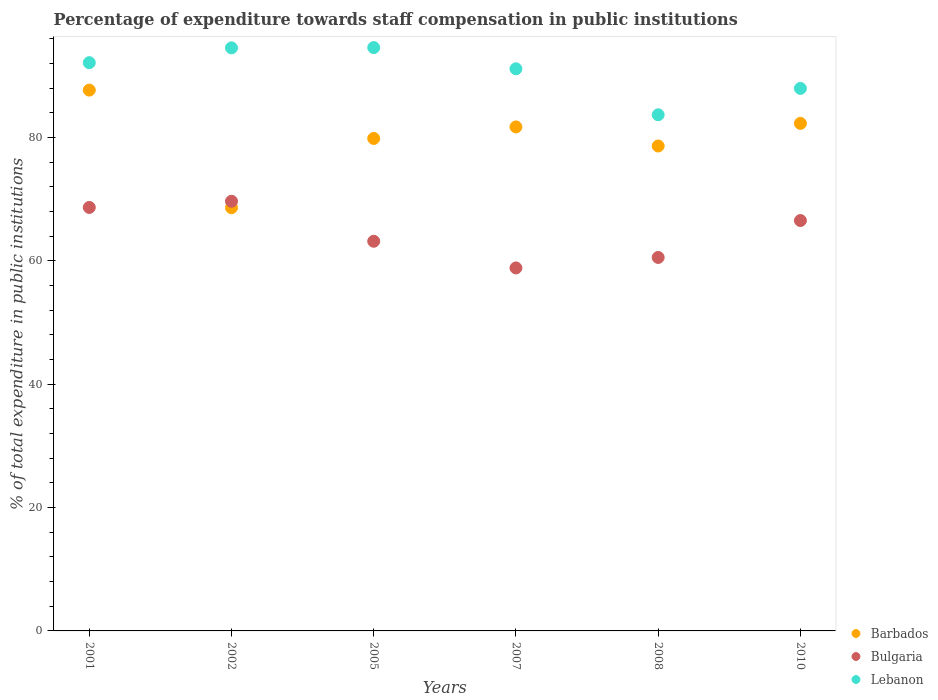What is the percentage of expenditure towards staff compensation in Bulgaria in 2010?
Offer a very short reply. 66.56. Across all years, what is the maximum percentage of expenditure towards staff compensation in Bulgaria?
Your response must be concise. 69.68. Across all years, what is the minimum percentage of expenditure towards staff compensation in Lebanon?
Your response must be concise. 83.71. In which year was the percentage of expenditure towards staff compensation in Bulgaria maximum?
Offer a terse response. 2002. In which year was the percentage of expenditure towards staff compensation in Lebanon minimum?
Your answer should be very brief. 2008. What is the total percentage of expenditure towards staff compensation in Bulgaria in the graph?
Make the answer very short. 387.56. What is the difference between the percentage of expenditure towards staff compensation in Lebanon in 2005 and that in 2007?
Keep it short and to the point. 3.44. What is the difference between the percentage of expenditure towards staff compensation in Lebanon in 2007 and the percentage of expenditure towards staff compensation in Bulgaria in 2010?
Keep it short and to the point. 24.61. What is the average percentage of expenditure towards staff compensation in Barbados per year?
Your response must be concise. 79.82. In the year 2007, what is the difference between the percentage of expenditure towards staff compensation in Barbados and percentage of expenditure towards staff compensation in Lebanon?
Your response must be concise. -9.42. What is the ratio of the percentage of expenditure towards staff compensation in Lebanon in 2001 to that in 2010?
Your answer should be very brief. 1.05. Is the percentage of expenditure towards staff compensation in Bulgaria in 2002 less than that in 2005?
Offer a terse response. No. Is the difference between the percentage of expenditure towards staff compensation in Barbados in 2008 and 2010 greater than the difference between the percentage of expenditure towards staff compensation in Lebanon in 2008 and 2010?
Keep it short and to the point. Yes. What is the difference between the highest and the second highest percentage of expenditure towards staff compensation in Lebanon?
Your answer should be very brief. 0.04. What is the difference between the highest and the lowest percentage of expenditure towards staff compensation in Barbados?
Your answer should be compact. 19.07. Is the percentage of expenditure towards staff compensation in Lebanon strictly greater than the percentage of expenditure towards staff compensation in Barbados over the years?
Provide a short and direct response. Yes. Is the percentage of expenditure towards staff compensation in Bulgaria strictly less than the percentage of expenditure towards staff compensation in Lebanon over the years?
Make the answer very short. Yes. How many dotlines are there?
Offer a terse response. 3. How many years are there in the graph?
Provide a short and direct response. 6. What is the difference between two consecutive major ticks on the Y-axis?
Give a very brief answer. 20. Are the values on the major ticks of Y-axis written in scientific E-notation?
Ensure brevity in your answer.  No. Does the graph contain grids?
Provide a succinct answer. No. What is the title of the graph?
Ensure brevity in your answer.  Percentage of expenditure towards staff compensation in public institutions. Does "Samoa" appear as one of the legend labels in the graph?
Ensure brevity in your answer.  No. What is the label or title of the X-axis?
Provide a short and direct response. Years. What is the label or title of the Y-axis?
Give a very brief answer. % of total expenditure in public institutions. What is the % of total expenditure in public institutions of Barbados in 2001?
Your answer should be compact. 87.71. What is the % of total expenditure in public institutions in Bulgaria in 2001?
Provide a succinct answer. 68.68. What is the % of total expenditure in public institutions in Lebanon in 2001?
Keep it short and to the point. 92.16. What is the % of total expenditure in public institutions in Barbados in 2002?
Ensure brevity in your answer.  68.64. What is the % of total expenditure in public institutions in Bulgaria in 2002?
Provide a succinct answer. 69.68. What is the % of total expenditure in public institutions of Lebanon in 2002?
Provide a short and direct response. 94.56. What is the % of total expenditure in public institutions in Barbados in 2005?
Provide a short and direct response. 79.87. What is the % of total expenditure in public institutions in Bulgaria in 2005?
Offer a terse response. 63.2. What is the % of total expenditure in public institutions in Lebanon in 2005?
Your answer should be very brief. 94.6. What is the % of total expenditure in public institutions in Barbados in 2007?
Offer a terse response. 81.74. What is the % of total expenditure in public institutions of Bulgaria in 2007?
Give a very brief answer. 58.87. What is the % of total expenditure in public institutions of Lebanon in 2007?
Offer a terse response. 91.16. What is the % of total expenditure in public institutions of Barbados in 2008?
Provide a succinct answer. 78.65. What is the % of total expenditure in public institutions in Bulgaria in 2008?
Offer a very short reply. 60.57. What is the % of total expenditure in public institutions in Lebanon in 2008?
Your answer should be very brief. 83.71. What is the % of total expenditure in public institutions of Barbados in 2010?
Your answer should be compact. 82.31. What is the % of total expenditure in public institutions in Bulgaria in 2010?
Provide a succinct answer. 66.56. What is the % of total expenditure in public institutions in Lebanon in 2010?
Your answer should be very brief. 87.98. Across all years, what is the maximum % of total expenditure in public institutions in Barbados?
Give a very brief answer. 87.71. Across all years, what is the maximum % of total expenditure in public institutions in Bulgaria?
Ensure brevity in your answer.  69.68. Across all years, what is the maximum % of total expenditure in public institutions of Lebanon?
Offer a terse response. 94.6. Across all years, what is the minimum % of total expenditure in public institutions in Barbados?
Make the answer very short. 68.64. Across all years, what is the minimum % of total expenditure in public institutions of Bulgaria?
Your response must be concise. 58.87. Across all years, what is the minimum % of total expenditure in public institutions of Lebanon?
Your response must be concise. 83.71. What is the total % of total expenditure in public institutions in Barbados in the graph?
Ensure brevity in your answer.  478.91. What is the total % of total expenditure in public institutions in Bulgaria in the graph?
Your answer should be compact. 387.56. What is the total % of total expenditure in public institutions of Lebanon in the graph?
Provide a short and direct response. 544.18. What is the difference between the % of total expenditure in public institutions of Barbados in 2001 and that in 2002?
Keep it short and to the point. 19.07. What is the difference between the % of total expenditure in public institutions in Bulgaria in 2001 and that in 2002?
Offer a very short reply. -1. What is the difference between the % of total expenditure in public institutions of Lebanon in 2001 and that in 2002?
Give a very brief answer. -2.41. What is the difference between the % of total expenditure in public institutions of Barbados in 2001 and that in 2005?
Your answer should be very brief. 7.84. What is the difference between the % of total expenditure in public institutions of Bulgaria in 2001 and that in 2005?
Make the answer very short. 5.48. What is the difference between the % of total expenditure in public institutions of Lebanon in 2001 and that in 2005?
Your answer should be compact. -2.45. What is the difference between the % of total expenditure in public institutions in Barbados in 2001 and that in 2007?
Your response must be concise. 5.97. What is the difference between the % of total expenditure in public institutions of Bulgaria in 2001 and that in 2007?
Give a very brief answer. 9.81. What is the difference between the % of total expenditure in public institutions in Barbados in 2001 and that in 2008?
Provide a succinct answer. 9.06. What is the difference between the % of total expenditure in public institutions in Bulgaria in 2001 and that in 2008?
Give a very brief answer. 8.11. What is the difference between the % of total expenditure in public institutions in Lebanon in 2001 and that in 2008?
Your answer should be very brief. 8.45. What is the difference between the % of total expenditure in public institutions in Barbados in 2001 and that in 2010?
Your answer should be very brief. 5.4. What is the difference between the % of total expenditure in public institutions in Bulgaria in 2001 and that in 2010?
Keep it short and to the point. 2.12. What is the difference between the % of total expenditure in public institutions of Lebanon in 2001 and that in 2010?
Ensure brevity in your answer.  4.17. What is the difference between the % of total expenditure in public institutions in Barbados in 2002 and that in 2005?
Ensure brevity in your answer.  -11.23. What is the difference between the % of total expenditure in public institutions of Bulgaria in 2002 and that in 2005?
Keep it short and to the point. 6.49. What is the difference between the % of total expenditure in public institutions in Lebanon in 2002 and that in 2005?
Provide a short and direct response. -0.04. What is the difference between the % of total expenditure in public institutions of Barbados in 2002 and that in 2007?
Offer a very short reply. -13.1. What is the difference between the % of total expenditure in public institutions of Bulgaria in 2002 and that in 2007?
Offer a very short reply. 10.81. What is the difference between the % of total expenditure in public institutions of Lebanon in 2002 and that in 2007?
Your answer should be compact. 3.4. What is the difference between the % of total expenditure in public institutions in Barbados in 2002 and that in 2008?
Ensure brevity in your answer.  -10.01. What is the difference between the % of total expenditure in public institutions of Bulgaria in 2002 and that in 2008?
Offer a very short reply. 9.11. What is the difference between the % of total expenditure in public institutions of Lebanon in 2002 and that in 2008?
Provide a short and direct response. 10.86. What is the difference between the % of total expenditure in public institutions of Barbados in 2002 and that in 2010?
Provide a succinct answer. -13.68. What is the difference between the % of total expenditure in public institutions of Bulgaria in 2002 and that in 2010?
Provide a succinct answer. 3.13. What is the difference between the % of total expenditure in public institutions of Lebanon in 2002 and that in 2010?
Keep it short and to the point. 6.58. What is the difference between the % of total expenditure in public institutions in Barbados in 2005 and that in 2007?
Keep it short and to the point. -1.87. What is the difference between the % of total expenditure in public institutions in Bulgaria in 2005 and that in 2007?
Make the answer very short. 4.33. What is the difference between the % of total expenditure in public institutions in Lebanon in 2005 and that in 2007?
Provide a succinct answer. 3.44. What is the difference between the % of total expenditure in public institutions in Barbados in 2005 and that in 2008?
Give a very brief answer. 1.22. What is the difference between the % of total expenditure in public institutions of Bulgaria in 2005 and that in 2008?
Offer a terse response. 2.62. What is the difference between the % of total expenditure in public institutions in Lebanon in 2005 and that in 2008?
Give a very brief answer. 10.9. What is the difference between the % of total expenditure in public institutions of Barbados in 2005 and that in 2010?
Your answer should be very brief. -2.45. What is the difference between the % of total expenditure in public institutions of Bulgaria in 2005 and that in 2010?
Give a very brief answer. -3.36. What is the difference between the % of total expenditure in public institutions of Lebanon in 2005 and that in 2010?
Offer a terse response. 6.62. What is the difference between the % of total expenditure in public institutions in Barbados in 2007 and that in 2008?
Your answer should be compact. 3.09. What is the difference between the % of total expenditure in public institutions of Bulgaria in 2007 and that in 2008?
Your answer should be very brief. -1.7. What is the difference between the % of total expenditure in public institutions of Lebanon in 2007 and that in 2008?
Your response must be concise. 7.46. What is the difference between the % of total expenditure in public institutions in Barbados in 2007 and that in 2010?
Provide a succinct answer. -0.57. What is the difference between the % of total expenditure in public institutions of Bulgaria in 2007 and that in 2010?
Make the answer very short. -7.69. What is the difference between the % of total expenditure in public institutions of Lebanon in 2007 and that in 2010?
Offer a very short reply. 3.18. What is the difference between the % of total expenditure in public institutions in Barbados in 2008 and that in 2010?
Give a very brief answer. -3.67. What is the difference between the % of total expenditure in public institutions in Bulgaria in 2008 and that in 2010?
Your response must be concise. -5.99. What is the difference between the % of total expenditure in public institutions of Lebanon in 2008 and that in 2010?
Keep it short and to the point. -4.28. What is the difference between the % of total expenditure in public institutions of Barbados in 2001 and the % of total expenditure in public institutions of Bulgaria in 2002?
Provide a short and direct response. 18.03. What is the difference between the % of total expenditure in public institutions in Barbados in 2001 and the % of total expenditure in public institutions in Lebanon in 2002?
Make the answer very short. -6.85. What is the difference between the % of total expenditure in public institutions in Bulgaria in 2001 and the % of total expenditure in public institutions in Lebanon in 2002?
Provide a short and direct response. -25.88. What is the difference between the % of total expenditure in public institutions in Barbados in 2001 and the % of total expenditure in public institutions in Bulgaria in 2005?
Provide a short and direct response. 24.51. What is the difference between the % of total expenditure in public institutions in Barbados in 2001 and the % of total expenditure in public institutions in Lebanon in 2005?
Your answer should be very brief. -6.89. What is the difference between the % of total expenditure in public institutions of Bulgaria in 2001 and the % of total expenditure in public institutions of Lebanon in 2005?
Offer a terse response. -25.92. What is the difference between the % of total expenditure in public institutions of Barbados in 2001 and the % of total expenditure in public institutions of Bulgaria in 2007?
Provide a short and direct response. 28.84. What is the difference between the % of total expenditure in public institutions of Barbados in 2001 and the % of total expenditure in public institutions of Lebanon in 2007?
Ensure brevity in your answer.  -3.45. What is the difference between the % of total expenditure in public institutions in Bulgaria in 2001 and the % of total expenditure in public institutions in Lebanon in 2007?
Offer a terse response. -22.48. What is the difference between the % of total expenditure in public institutions of Barbados in 2001 and the % of total expenditure in public institutions of Bulgaria in 2008?
Provide a short and direct response. 27.14. What is the difference between the % of total expenditure in public institutions in Barbados in 2001 and the % of total expenditure in public institutions in Lebanon in 2008?
Offer a terse response. 4. What is the difference between the % of total expenditure in public institutions of Bulgaria in 2001 and the % of total expenditure in public institutions of Lebanon in 2008?
Your response must be concise. -15.03. What is the difference between the % of total expenditure in public institutions in Barbados in 2001 and the % of total expenditure in public institutions in Bulgaria in 2010?
Provide a short and direct response. 21.15. What is the difference between the % of total expenditure in public institutions of Barbados in 2001 and the % of total expenditure in public institutions of Lebanon in 2010?
Your answer should be compact. -0.27. What is the difference between the % of total expenditure in public institutions in Bulgaria in 2001 and the % of total expenditure in public institutions in Lebanon in 2010?
Give a very brief answer. -19.3. What is the difference between the % of total expenditure in public institutions in Barbados in 2002 and the % of total expenditure in public institutions in Bulgaria in 2005?
Your answer should be compact. 5.44. What is the difference between the % of total expenditure in public institutions of Barbados in 2002 and the % of total expenditure in public institutions of Lebanon in 2005?
Your answer should be very brief. -25.97. What is the difference between the % of total expenditure in public institutions of Bulgaria in 2002 and the % of total expenditure in public institutions of Lebanon in 2005?
Your answer should be compact. -24.92. What is the difference between the % of total expenditure in public institutions in Barbados in 2002 and the % of total expenditure in public institutions in Bulgaria in 2007?
Offer a very short reply. 9.77. What is the difference between the % of total expenditure in public institutions of Barbados in 2002 and the % of total expenditure in public institutions of Lebanon in 2007?
Offer a terse response. -22.52. What is the difference between the % of total expenditure in public institutions of Bulgaria in 2002 and the % of total expenditure in public institutions of Lebanon in 2007?
Provide a short and direct response. -21.48. What is the difference between the % of total expenditure in public institutions in Barbados in 2002 and the % of total expenditure in public institutions in Bulgaria in 2008?
Give a very brief answer. 8.07. What is the difference between the % of total expenditure in public institutions of Barbados in 2002 and the % of total expenditure in public institutions of Lebanon in 2008?
Offer a very short reply. -15.07. What is the difference between the % of total expenditure in public institutions of Bulgaria in 2002 and the % of total expenditure in public institutions of Lebanon in 2008?
Provide a short and direct response. -14.02. What is the difference between the % of total expenditure in public institutions in Barbados in 2002 and the % of total expenditure in public institutions in Bulgaria in 2010?
Provide a short and direct response. 2.08. What is the difference between the % of total expenditure in public institutions of Barbados in 2002 and the % of total expenditure in public institutions of Lebanon in 2010?
Keep it short and to the point. -19.35. What is the difference between the % of total expenditure in public institutions of Bulgaria in 2002 and the % of total expenditure in public institutions of Lebanon in 2010?
Offer a very short reply. -18.3. What is the difference between the % of total expenditure in public institutions of Barbados in 2005 and the % of total expenditure in public institutions of Bulgaria in 2007?
Ensure brevity in your answer.  21. What is the difference between the % of total expenditure in public institutions in Barbados in 2005 and the % of total expenditure in public institutions in Lebanon in 2007?
Provide a succinct answer. -11.3. What is the difference between the % of total expenditure in public institutions of Bulgaria in 2005 and the % of total expenditure in public institutions of Lebanon in 2007?
Provide a succinct answer. -27.97. What is the difference between the % of total expenditure in public institutions of Barbados in 2005 and the % of total expenditure in public institutions of Bulgaria in 2008?
Offer a very short reply. 19.3. What is the difference between the % of total expenditure in public institutions in Barbados in 2005 and the % of total expenditure in public institutions in Lebanon in 2008?
Give a very brief answer. -3.84. What is the difference between the % of total expenditure in public institutions in Bulgaria in 2005 and the % of total expenditure in public institutions in Lebanon in 2008?
Offer a very short reply. -20.51. What is the difference between the % of total expenditure in public institutions of Barbados in 2005 and the % of total expenditure in public institutions of Bulgaria in 2010?
Offer a terse response. 13.31. What is the difference between the % of total expenditure in public institutions in Barbados in 2005 and the % of total expenditure in public institutions in Lebanon in 2010?
Ensure brevity in your answer.  -8.12. What is the difference between the % of total expenditure in public institutions of Bulgaria in 2005 and the % of total expenditure in public institutions of Lebanon in 2010?
Offer a very short reply. -24.79. What is the difference between the % of total expenditure in public institutions in Barbados in 2007 and the % of total expenditure in public institutions in Bulgaria in 2008?
Offer a very short reply. 21.17. What is the difference between the % of total expenditure in public institutions in Barbados in 2007 and the % of total expenditure in public institutions in Lebanon in 2008?
Ensure brevity in your answer.  -1.97. What is the difference between the % of total expenditure in public institutions in Bulgaria in 2007 and the % of total expenditure in public institutions in Lebanon in 2008?
Offer a terse response. -24.84. What is the difference between the % of total expenditure in public institutions in Barbados in 2007 and the % of total expenditure in public institutions in Bulgaria in 2010?
Ensure brevity in your answer.  15.18. What is the difference between the % of total expenditure in public institutions in Barbados in 2007 and the % of total expenditure in public institutions in Lebanon in 2010?
Make the answer very short. -6.24. What is the difference between the % of total expenditure in public institutions of Bulgaria in 2007 and the % of total expenditure in public institutions of Lebanon in 2010?
Ensure brevity in your answer.  -29.11. What is the difference between the % of total expenditure in public institutions of Barbados in 2008 and the % of total expenditure in public institutions of Bulgaria in 2010?
Provide a short and direct response. 12.09. What is the difference between the % of total expenditure in public institutions in Barbados in 2008 and the % of total expenditure in public institutions in Lebanon in 2010?
Your answer should be very brief. -9.34. What is the difference between the % of total expenditure in public institutions of Bulgaria in 2008 and the % of total expenditure in public institutions of Lebanon in 2010?
Your answer should be compact. -27.41. What is the average % of total expenditure in public institutions in Barbados per year?
Provide a succinct answer. 79.82. What is the average % of total expenditure in public institutions in Bulgaria per year?
Offer a terse response. 64.59. What is the average % of total expenditure in public institutions in Lebanon per year?
Your answer should be compact. 90.7. In the year 2001, what is the difference between the % of total expenditure in public institutions in Barbados and % of total expenditure in public institutions in Bulgaria?
Keep it short and to the point. 19.03. In the year 2001, what is the difference between the % of total expenditure in public institutions of Barbados and % of total expenditure in public institutions of Lebanon?
Your answer should be compact. -4.45. In the year 2001, what is the difference between the % of total expenditure in public institutions of Bulgaria and % of total expenditure in public institutions of Lebanon?
Ensure brevity in your answer.  -23.48. In the year 2002, what is the difference between the % of total expenditure in public institutions in Barbados and % of total expenditure in public institutions in Bulgaria?
Your response must be concise. -1.05. In the year 2002, what is the difference between the % of total expenditure in public institutions in Barbados and % of total expenditure in public institutions in Lebanon?
Give a very brief answer. -25.92. In the year 2002, what is the difference between the % of total expenditure in public institutions of Bulgaria and % of total expenditure in public institutions of Lebanon?
Keep it short and to the point. -24.88. In the year 2005, what is the difference between the % of total expenditure in public institutions of Barbados and % of total expenditure in public institutions of Bulgaria?
Make the answer very short. 16.67. In the year 2005, what is the difference between the % of total expenditure in public institutions of Barbados and % of total expenditure in public institutions of Lebanon?
Your answer should be very brief. -14.74. In the year 2005, what is the difference between the % of total expenditure in public institutions in Bulgaria and % of total expenditure in public institutions in Lebanon?
Provide a short and direct response. -31.41. In the year 2007, what is the difference between the % of total expenditure in public institutions of Barbados and % of total expenditure in public institutions of Bulgaria?
Provide a short and direct response. 22.87. In the year 2007, what is the difference between the % of total expenditure in public institutions in Barbados and % of total expenditure in public institutions in Lebanon?
Provide a short and direct response. -9.42. In the year 2007, what is the difference between the % of total expenditure in public institutions of Bulgaria and % of total expenditure in public institutions of Lebanon?
Provide a short and direct response. -32.29. In the year 2008, what is the difference between the % of total expenditure in public institutions in Barbados and % of total expenditure in public institutions in Bulgaria?
Offer a very short reply. 18.08. In the year 2008, what is the difference between the % of total expenditure in public institutions in Barbados and % of total expenditure in public institutions in Lebanon?
Ensure brevity in your answer.  -5.06. In the year 2008, what is the difference between the % of total expenditure in public institutions in Bulgaria and % of total expenditure in public institutions in Lebanon?
Make the answer very short. -23.14. In the year 2010, what is the difference between the % of total expenditure in public institutions in Barbados and % of total expenditure in public institutions in Bulgaria?
Offer a terse response. 15.76. In the year 2010, what is the difference between the % of total expenditure in public institutions in Barbados and % of total expenditure in public institutions in Lebanon?
Your answer should be compact. -5.67. In the year 2010, what is the difference between the % of total expenditure in public institutions of Bulgaria and % of total expenditure in public institutions of Lebanon?
Give a very brief answer. -21.43. What is the ratio of the % of total expenditure in public institutions in Barbados in 2001 to that in 2002?
Make the answer very short. 1.28. What is the ratio of the % of total expenditure in public institutions of Bulgaria in 2001 to that in 2002?
Ensure brevity in your answer.  0.99. What is the ratio of the % of total expenditure in public institutions of Lebanon in 2001 to that in 2002?
Offer a terse response. 0.97. What is the ratio of the % of total expenditure in public institutions in Barbados in 2001 to that in 2005?
Make the answer very short. 1.1. What is the ratio of the % of total expenditure in public institutions of Bulgaria in 2001 to that in 2005?
Offer a very short reply. 1.09. What is the ratio of the % of total expenditure in public institutions in Lebanon in 2001 to that in 2005?
Ensure brevity in your answer.  0.97. What is the ratio of the % of total expenditure in public institutions in Barbados in 2001 to that in 2007?
Your answer should be compact. 1.07. What is the ratio of the % of total expenditure in public institutions of Bulgaria in 2001 to that in 2007?
Give a very brief answer. 1.17. What is the ratio of the % of total expenditure in public institutions of Lebanon in 2001 to that in 2007?
Keep it short and to the point. 1.01. What is the ratio of the % of total expenditure in public institutions of Barbados in 2001 to that in 2008?
Offer a terse response. 1.12. What is the ratio of the % of total expenditure in public institutions of Bulgaria in 2001 to that in 2008?
Ensure brevity in your answer.  1.13. What is the ratio of the % of total expenditure in public institutions of Lebanon in 2001 to that in 2008?
Provide a short and direct response. 1.1. What is the ratio of the % of total expenditure in public institutions of Barbados in 2001 to that in 2010?
Offer a very short reply. 1.07. What is the ratio of the % of total expenditure in public institutions in Bulgaria in 2001 to that in 2010?
Your answer should be compact. 1.03. What is the ratio of the % of total expenditure in public institutions in Lebanon in 2001 to that in 2010?
Keep it short and to the point. 1.05. What is the ratio of the % of total expenditure in public institutions in Barbados in 2002 to that in 2005?
Your answer should be very brief. 0.86. What is the ratio of the % of total expenditure in public institutions in Bulgaria in 2002 to that in 2005?
Your answer should be compact. 1.1. What is the ratio of the % of total expenditure in public institutions of Lebanon in 2002 to that in 2005?
Ensure brevity in your answer.  1. What is the ratio of the % of total expenditure in public institutions in Barbados in 2002 to that in 2007?
Make the answer very short. 0.84. What is the ratio of the % of total expenditure in public institutions in Bulgaria in 2002 to that in 2007?
Offer a very short reply. 1.18. What is the ratio of the % of total expenditure in public institutions in Lebanon in 2002 to that in 2007?
Give a very brief answer. 1.04. What is the ratio of the % of total expenditure in public institutions of Barbados in 2002 to that in 2008?
Offer a very short reply. 0.87. What is the ratio of the % of total expenditure in public institutions in Bulgaria in 2002 to that in 2008?
Offer a terse response. 1.15. What is the ratio of the % of total expenditure in public institutions in Lebanon in 2002 to that in 2008?
Your answer should be compact. 1.13. What is the ratio of the % of total expenditure in public institutions in Barbados in 2002 to that in 2010?
Offer a very short reply. 0.83. What is the ratio of the % of total expenditure in public institutions of Bulgaria in 2002 to that in 2010?
Offer a terse response. 1.05. What is the ratio of the % of total expenditure in public institutions in Lebanon in 2002 to that in 2010?
Give a very brief answer. 1.07. What is the ratio of the % of total expenditure in public institutions in Barbados in 2005 to that in 2007?
Your response must be concise. 0.98. What is the ratio of the % of total expenditure in public institutions of Bulgaria in 2005 to that in 2007?
Provide a short and direct response. 1.07. What is the ratio of the % of total expenditure in public institutions of Lebanon in 2005 to that in 2007?
Keep it short and to the point. 1.04. What is the ratio of the % of total expenditure in public institutions of Barbados in 2005 to that in 2008?
Make the answer very short. 1.02. What is the ratio of the % of total expenditure in public institutions of Bulgaria in 2005 to that in 2008?
Give a very brief answer. 1.04. What is the ratio of the % of total expenditure in public institutions of Lebanon in 2005 to that in 2008?
Keep it short and to the point. 1.13. What is the ratio of the % of total expenditure in public institutions of Barbados in 2005 to that in 2010?
Your answer should be very brief. 0.97. What is the ratio of the % of total expenditure in public institutions in Bulgaria in 2005 to that in 2010?
Your response must be concise. 0.95. What is the ratio of the % of total expenditure in public institutions in Lebanon in 2005 to that in 2010?
Give a very brief answer. 1.08. What is the ratio of the % of total expenditure in public institutions of Barbados in 2007 to that in 2008?
Your answer should be compact. 1.04. What is the ratio of the % of total expenditure in public institutions in Bulgaria in 2007 to that in 2008?
Give a very brief answer. 0.97. What is the ratio of the % of total expenditure in public institutions in Lebanon in 2007 to that in 2008?
Provide a short and direct response. 1.09. What is the ratio of the % of total expenditure in public institutions in Barbados in 2007 to that in 2010?
Make the answer very short. 0.99. What is the ratio of the % of total expenditure in public institutions of Bulgaria in 2007 to that in 2010?
Your response must be concise. 0.88. What is the ratio of the % of total expenditure in public institutions in Lebanon in 2007 to that in 2010?
Keep it short and to the point. 1.04. What is the ratio of the % of total expenditure in public institutions in Barbados in 2008 to that in 2010?
Offer a terse response. 0.96. What is the ratio of the % of total expenditure in public institutions in Bulgaria in 2008 to that in 2010?
Provide a short and direct response. 0.91. What is the ratio of the % of total expenditure in public institutions of Lebanon in 2008 to that in 2010?
Provide a short and direct response. 0.95. What is the difference between the highest and the second highest % of total expenditure in public institutions of Barbados?
Your response must be concise. 5.4. What is the difference between the highest and the second highest % of total expenditure in public institutions of Lebanon?
Provide a short and direct response. 0.04. What is the difference between the highest and the lowest % of total expenditure in public institutions of Barbados?
Your response must be concise. 19.07. What is the difference between the highest and the lowest % of total expenditure in public institutions of Bulgaria?
Your answer should be very brief. 10.81. What is the difference between the highest and the lowest % of total expenditure in public institutions of Lebanon?
Give a very brief answer. 10.9. 